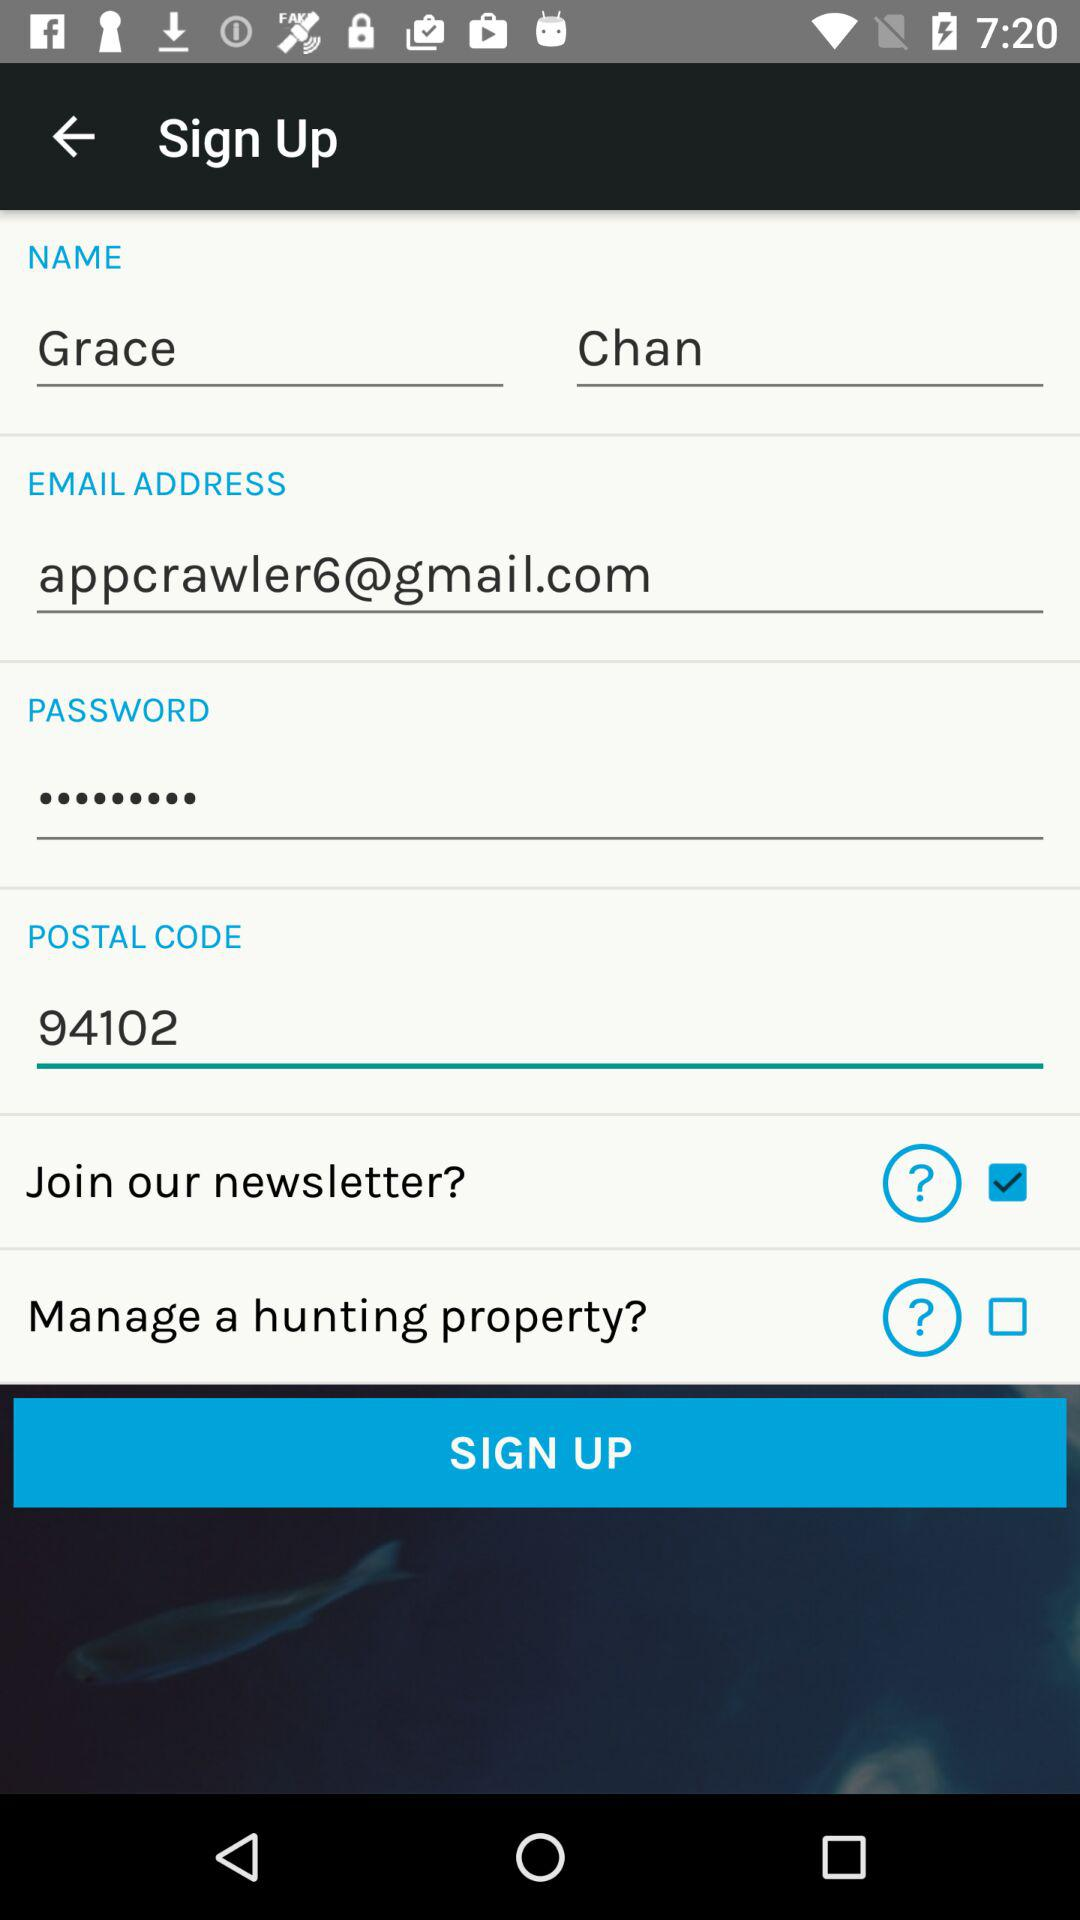What is the "POSTAL CODE"? The "POSTAL CODE" is 94102. 